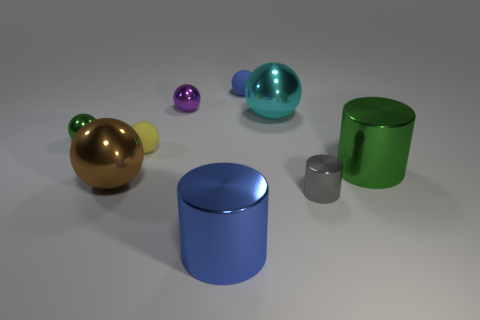There is a big metal sphere that is right of the blue shiny cylinder; is its color the same as the tiny cylinder?
Keep it short and to the point. No. Is there a small rubber ball of the same color as the small cylinder?
Offer a terse response. No. What number of metal objects are both in front of the large green metal cylinder and behind the small gray shiny cylinder?
Keep it short and to the point. 1. Are there fewer tiny metal balls in front of the big brown shiny ball than gray shiny cylinders in front of the tiny blue object?
Ensure brevity in your answer.  Yes. What is the material of the large thing that is right of the blue rubber object and in front of the tiny yellow matte object?
Give a very brief answer. Metal. There is a blue object that is the same material as the tiny purple object; what shape is it?
Make the answer very short. Cylinder. There is a large ball that is to the left of the big metal cylinder in front of the brown metallic thing; what is its material?
Provide a short and direct response. Metal. How many other things are the same shape as the blue shiny thing?
Ensure brevity in your answer.  2. Do the green metallic thing that is left of the cyan ball and the object behind the small purple ball have the same shape?
Give a very brief answer. Yes. Is there any other thing that is made of the same material as the purple thing?
Ensure brevity in your answer.  Yes. 